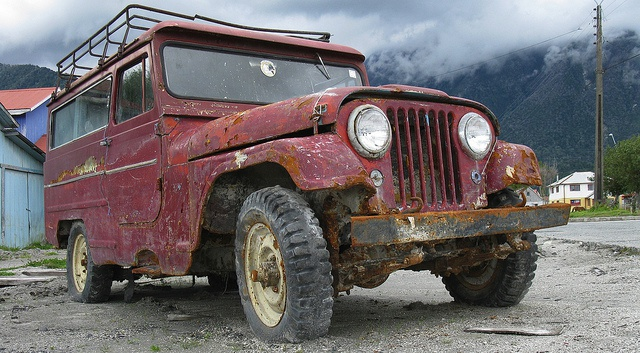Describe the objects in this image and their specific colors. I can see truck in white, black, gray, brown, and maroon tones, car in white, black, gray, brown, and maroon tones, and car in white, darkgreen, maroon, tan, and khaki tones in this image. 